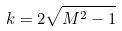<formula> <loc_0><loc_0><loc_500><loc_500>k = 2 \sqrt { M ^ { 2 } - 1 }</formula> 